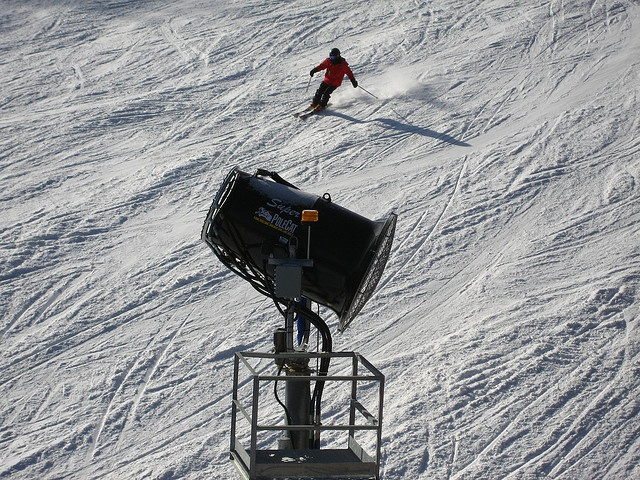Describe the objects in this image and their specific colors. I can see people in gray, black, maroon, and darkgray tones, people in gray, black, navy, and darkgray tones, and skis in gray, black, darkgray, and lightgray tones in this image. 